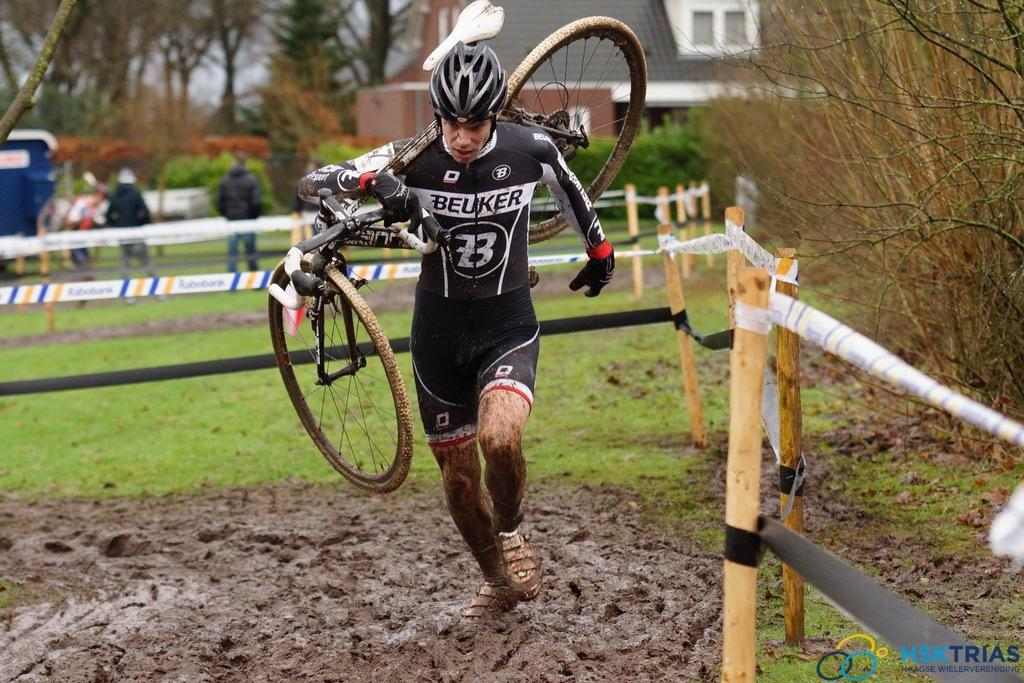<image>
Give a short and clear explanation of the subsequent image. A man in a cyclist uniform that has the name Beuker on the front, is running through mud, carrying his bicycle. 